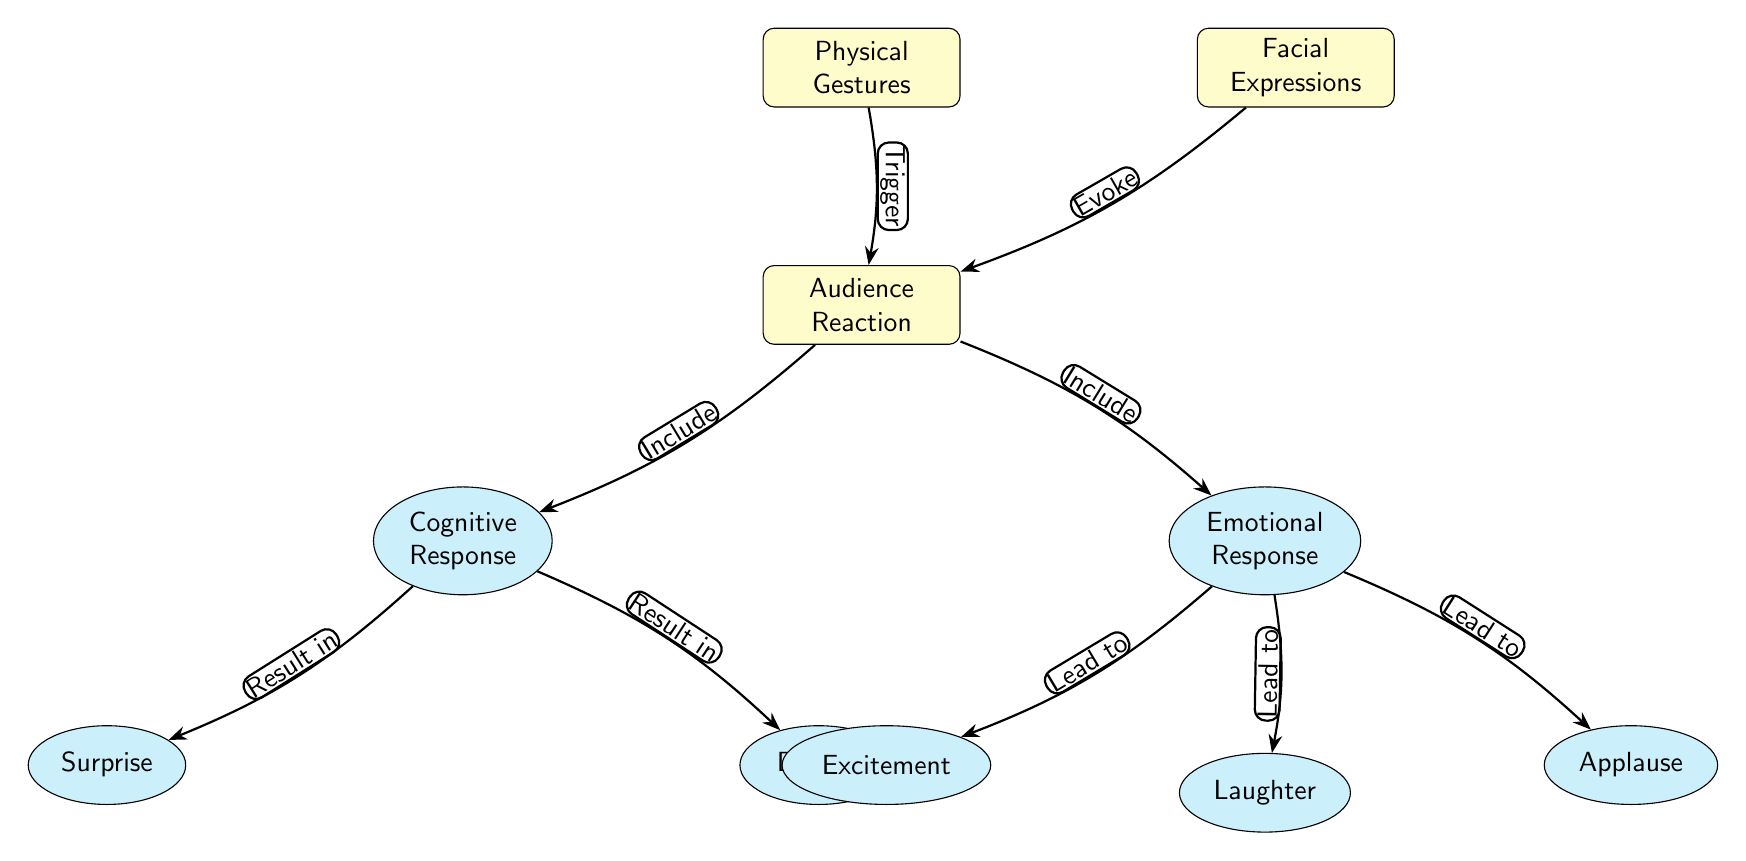What are the main categories shown in the diagram? The diagram contains two main categories represented by the nodes: Physical Gestures and Facial Expressions. These are the primary sources of audience reaction.
Answer: Physical Gestures, Facial Expressions How many nodes are present in the diagram? The diagram features a total of 7 nodes. This is calculated by counting the main and sub-nodes displayed in the diagram.
Answer: 7 What type of response is categorized under audience reaction? The diagram lists two types of responses under audience reaction: Cognitive Response and Emotional Response. These nodes illustrate different audience interpretations.
Answer: Cognitive Response, Emotional Response Which response results from cognitive processing? The cognitive response leads to two outcomes: Surprise and Delight. These are the emotions processed by the audience when triggered by physical gestures and facial expressions.
Answer: Surprise, Delight What leads to laughter according to the diagram? Laughter arises as a response derived from the Emotional Response node, which also includes excitement and applause as other reactions.
Answer: Laughter What triggers the audience reaction in the diagram? The audience reaction is triggered by Physical Gestures and Facial Expressions as indicated by the arrows connecting these nodes to the Audience Reaction node.
Answer: Physical Gestures, Facial Expressions How many emotional responses are identified in the diagram? The diagram identifies three emotional responses: Excitement, Laughter, and Applause. These responses are categorized specifically under the Emotional Response node.
Answer: 3 What is the relationship between facial expressions and audience reaction? Facial expressions evoke reactions from the audience, as shown by the direct connection from the Facial Expressions node to the Audience Reaction node in the diagram.
Answer: Evoke Which cognitive response results from audience reaction? The cognitive response includes Surprise and Delight, which are the emotional implications processed by the audience following their reaction.
Answer: Surprise, Delight 